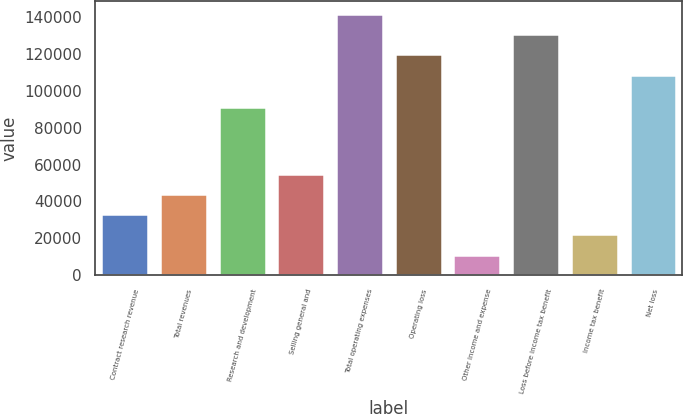Convert chart to OTSL. <chart><loc_0><loc_0><loc_500><loc_500><bar_chart><fcel>Contract research revenue<fcel>Total revenues<fcel>Research and development<fcel>Selling general and<fcel>Total operating expenses<fcel>Operating loss<fcel>Other income and expense<fcel>Loss before income tax benefit<fcel>Income tax benefit<fcel>Net loss<nl><fcel>33104.4<fcel>44137.9<fcel>91388<fcel>55171.4<fcel>141851<fcel>119784<fcel>11037.4<fcel>130817<fcel>22070.9<fcel>108750<nl></chart> 